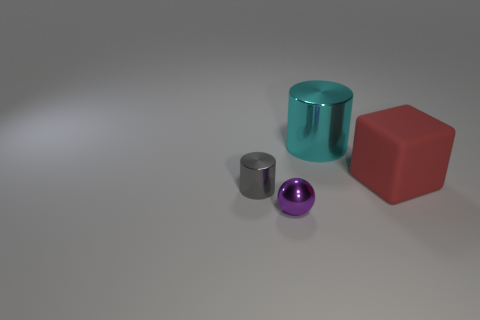There is a cylinder that is left of the metallic object to the right of the small purple ball; is there a shiny object in front of it?
Offer a very short reply. Yes. What size is the thing to the right of the cylinder to the right of the gray cylinder?
Ensure brevity in your answer.  Large. How many things are large things to the left of the red rubber thing or small cyan cubes?
Provide a succinct answer. 1. Is there a cyan metal thing of the same size as the matte thing?
Ensure brevity in your answer.  Yes. There is a cylinder in front of the large red thing; is there a shiny cylinder that is to the right of it?
Ensure brevity in your answer.  Yes. How many blocks are either gray shiny objects or large red rubber objects?
Ensure brevity in your answer.  1. Are there any other large things that have the same shape as the gray object?
Offer a terse response. Yes. The large shiny object has what shape?
Your response must be concise. Cylinder. What number of things are either small balls or tiny gray things?
Your answer should be compact. 2. Is the size of the metallic object in front of the small gray object the same as the thing that is behind the red rubber cube?
Your answer should be very brief. No. 